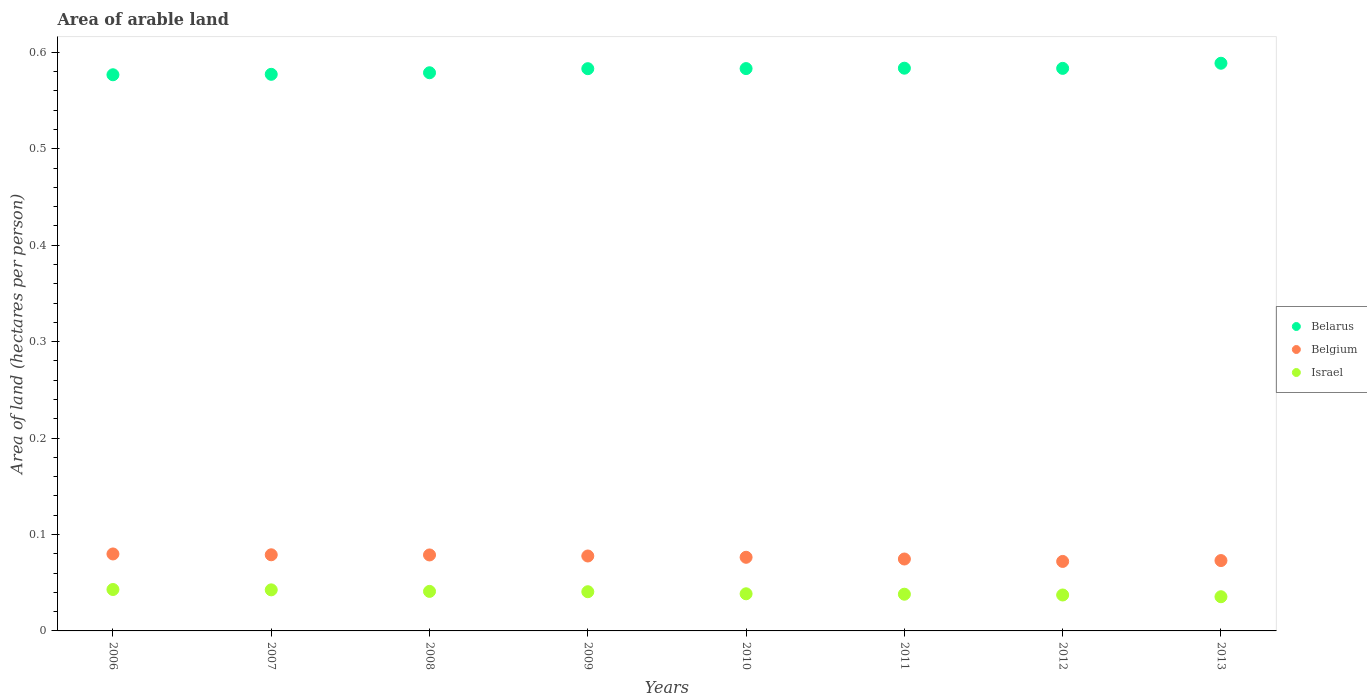How many different coloured dotlines are there?
Offer a terse response. 3. Is the number of dotlines equal to the number of legend labels?
Your answer should be very brief. Yes. What is the total arable land in Israel in 2007?
Offer a terse response. 0.04. Across all years, what is the maximum total arable land in Belarus?
Make the answer very short. 0.59. Across all years, what is the minimum total arable land in Belarus?
Keep it short and to the point. 0.58. In which year was the total arable land in Belgium maximum?
Ensure brevity in your answer.  2006. What is the total total arable land in Israel in the graph?
Provide a short and direct response. 0.32. What is the difference between the total arable land in Belgium in 2011 and that in 2013?
Give a very brief answer. 0. What is the difference between the total arable land in Belarus in 2006 and the total arable land in Belgium in 2010?
Provide a succinct answer. 0.5. What is the average total arable land in Belarus per year?
Your response must be concise. 0.58. In the year 2006, what is the difference between the total arable land in Belarus and total arable land in Belgium?
Provide a short and direct response. 0.5. In how many years, is the total arable land in Belarus greater than 0.54 hectares per person?
Keep it short and to the point. 8. What is the ratio of the total arable land in Israel in 2012 to that in 2013?
Your response must be concise. 1.05. Is the difference between the total arable land in Belarus in 2006 and 2011 greater than the difference between the total arable land in Belgium in 2006 and 2011?
Your answer should be compact. No. What is the difference between the highest and the second highest total arable land in Belgium?
Offer a very short reply. 0. What is the difference between the highest and the lowest total arable land in Belgium?
Keep it short and to the point. 0.01. Is the sum of the total arable land in Israel in 2008 and 2013 greater than the maximum total arable land in Belgium across all years?
Offer a terse response. No. Is the total arable land in Belarus strictly greater than the total arable land in Belgium over the years?
Give a very brief answer. Yes. How many dotlines are there?
Offer a very short reply. 3. How many years are there in the graph?
Your answer should be very brief. 8. What is the difference between two consecutive major ticks on the Y-axis?
Keep it short and to the point. 0.1. Are the values on the major ticks of Y-axis written in scientific E-notation?
Provide a short and direct response. No. Where does the legend appear in the graph?
Ensure brevity in your answer.  Center right. How are the legend labels stacked?
Offer a very short reply. Vertical. What is the title of the graph?
Provide a succinct answer. Area of arable land. What is the label or title of the X-axis?
Your response must be concise. Years. What is the label or title of the Y-axis?
Give a very brief answer. Area of land (hectares per person). What is the Area of land (hectares per person) in Belarus in 2006?
Provide a succinct answer. 0.58. What is the Area of land (hectares per person) in Belgium in 2006?
Your answer should be very brief. 0.08. What is the Area of land (hectares per person) in Israel in 2006?
Provide a succinct answer. 0.04. What is the Area of land (hectares per person) of Belarus in 2007?
Your response must be concise. 0.58. What is the Area of land (hectares per person) of Belgium in 2007?
Offer a terse response. 0.08. What is the Area of land (hectares per person) of Israel in 2007?
Ensure brevity in your answer.  0.04. What is the Area of land (hectares per person) of Belarus in 2008?
Provide a succinct answer. 0.58. What is the Area of land (hectares per person) of Belgium in 2008?
Make the answer very short. 0.08. What is the Area of land (hectares per person) of Israel in 2008?
Your answer should be very brief. 0.04. What is the Area of land (hectares per person) in Belarus in 2009?
Your answer should be compact. 0.58. What is the Area of land (hectares per person) of Belgium in 2009?
Offer a very short reply. 0.08. What is the Area of land (hectares per person) of Israel in 2009?
Keep it short and to the point. 0.04. What is the Area of land (hectares per person) of Belarus in 2010?
Offer a terse response. 0.58. What is the Area of land (hectares per person) of Belgium in 2010?
Offer a terse response. 0.08. What is the Area of land (hectares per person) in Israel in 2010?
Provide a short and direct response. 0.04. What is the Area of land (hectares per person) of Belarus in 2011?
Ensure brevity in your answer.  0.58. What is the Area of land (hectares per person) of Belgium in 2011?
Your answer should be compact. 0.07. What is the Area of land (hectares per person) in Israel in 2011?
Ensure brevity in your answer.  0.04. What is the Area of land (hectares per person) of Belarus in 2012?
Give a very brief answer. 0.58. What is the Area of land (hectares per person) of Belgium in 2012?
Your answer should be compact. 0.07. What is the Area of land (hectares per person) in Israel in 2012?
Keep it short and to the point. 0.04. What is the Area of land (hectares per person) of Belarus in 2013?
Offer a very short reply. 0.59. What is the Area of land (hectares per person) in Belgium in 2013?
Your answer should be very brief. 0.07. What is the Area of land (hectares per person) in Israel in 2013?
Provide a short and direct response. 0.04. Across all years, what is the maximum Area of land (hectares per person) of Belarus?
Keep it short and to the point. 0.59. Across all years, what is the maximum Area of land (hectares per person) in Belgium?
Offer a very short reply. 0.08. Across all years, what is the maximum Area of land (hectares per person) of Israel?
Keep it short and to the point. 0.04. Across all years, what is the minimum Area of land (hectares per person) in Belarus?
Offer a very short reply. 0.58. Across all years, what is the minimum Area of land (hectares per person) in Belgium?
Your answer should be compact. 0.07. Across all years, what is the minimum Area of land (hectares per person) of Israel?
Offer a terse response. 0.04. What is the total Area of land (hectares per person) in Belarus in the graph?
Keep it short and to the point. 4.66. What is the total Area of land (hectares per person) in Belgium in the graph?
Provide a succinct answer. 0.61. What is the total Area of land (hectares per person) of Israel in the graph?
Offer a terse response. 0.32. What is the difference between the Area of land (hectares per person) in Belarus in 2006 and that in 2007?
Provide a short and direct response. -0. What is the difference between the Area of land (hectares per person) in Belgium in 2006 and that in 2007?
Ensure brevity in your answer.  0. What is the difference between the Area of land (hectares per person) in Israel in 2006 and that in 2007?
Your response must be concise. 0. What is the difference between the Area of land (hectares per person) of Belarus in 2006 and that in 2008?
Offer a terse response. -0. What is the difference between the Area of land (hectares per person) in Israel in 2006 and that in 2008?
Give a very brief answer. 0. What is the difference between the Area of land (hectares per person) of Belarus in 2006 and that in 2009?
Ensure brevity in your answer.  -0.01. What is the difference between the Area of land (hectares per person) of Belgium in 2006 and that in 2009?
Offer a very short reply. 0. What is the difference between the Area of land (hectares per person) of Israel in 2006 and that in 2009?
Make the answer very short. 0. What is the difference between the Area of land (hectares per person) in Belarus in 2006 and that in 2010?
Your answer should be compact. -0.01. What is the difference between the Area of land (hectares per person) in Belgium in 2006 and that in 2010?
Keep it short and to the point. 0. What is the difference between the Area of land (hectares per person) in Israel in 2006 and that in 2010?
Offer a very short reply. 0. What is the difference between the Area of land (hectares per person) in Belarus in 2006 and that in 2011?
Ensure brevity in your answer.  -0.01. What is the difference between the Area of land (hectares per person) of Belgium in 2006 and that in 2011?
Give a very brief answer. 0.01. What is the difference between the Area of land (hectares per person) of Israel in 2006 and that in 2011?
Make the answer very short. 0. What is the difference between the Area of land (hectares per person) in Belarus in 2006 and that in 2012?
Make the answer very short. -0.01. What is the difference between the Area of land (hectares per person) of Belgium in 2006 and that in 2012?
Give a very brief answer. 0.01. What is the difference between the Area of land (hectares per person) of Israel in 2006 and that in 2012?
Your answer should be compact. 0.01. What is the difference between the Area of land (hectares per person) in Belarus in 2006 and that in 2013?
Provide a succinct answer. -0.01. What is the difference between the Area of land (hectares per person) in Belgium in 2006 and that in 2013?
Your answer should be compact. 0.01. What is the difference between the Area of land (hectares per person) in Israel in 2006 and that in 2013?
Your answer should be very brief. 0.01. What is the difference between the Area of land (hectares per person) in Belarus in 2007 and that in 2008?
Your answer should be compact. -0. What is the difference between the Area of land (hectares per person) of Belgium in 2007 and that in 2008?
Offer a very short reply. 0. What is the difference between the Area of land (hectares per person) in Israel in 2007 and that in 2008?
Ensure brevity in your answer.  0. What is the difference between the Area of land (hectares per person) in Belarus in 2007 and that in 2009?
Provide a succinct answer. -0.01. What is the difference between the Area of land (hectares per person) in Belgium in 2007 and that in 2009?
Your answer should be compact. 0. What is the difference between the Area of land (hectares per person) in Israel in 2007 and that in 2009?
Your answer should be very brief. 0. What is the difference between the Area of land (hectares per person) in Belarus in 2007 and that in 2010?
Ensure brevity in your answer.  -0.01. What is the difference between the Area of land (hectares per person) of Belgium in 2007 and that in 2010?
Provide a succinct answer. 0. What is the difference between the Area of land (hectares per person) in Israel in 2007 and that in 2010?
Ensure brevity in your answer.  0. What is the difference between the Area of land (hectares per person) of Belarus in 2007 and that in 2011?
Offer a very short reply. -0.01. What is the difference between the Area of land (hectares per person) of Belgium in 2007 and that in 2011?
Provide a succinct answer. 0. What is the difference between the Area of land (hectares per person) of Israel in 2007 and that in 2011?
Make the answer very short. 0. What is the difference between the Area of land (hectares per person) in Belarus in 2007 and that in 2012?
Give a very brief answer. -0.01. What is the difference between the Area of land (hectares per person) in Belgium in 2007 and that in 2012?
Your answer should be compact. 0.01. What is the difference between the Area of land (hectares per person) of Israel in 2007 and that in 2012?
Your response must be concise. 0.01. What is the difference between the Area of land (hectares per person) in Belarus in 2007 and that in 2013?
Make the answer very short. -0.01. What is the difference between the Area of land (hectares per person) of Belgium in 2007 and that in 2013?
Provide a short and direct response. 0.01. What is the difference between the Area of land (hectares per person) of Israel in 2007 and that in 2013?
Offer a terse response. 0.01. What is the difference between the Area of land (hectares per person) in Belarus in 2008 and that in 2009?
Give a very brief answer. -0. What is the difference between the Area of land (hectares per person) of Belgium in 2008 and that in 2009?
Keep it short and to the point. 0. What is the difference between the Area of land (hectares per person) in Israel in 2008 and that in 2009?
Keep it short and to the point. 0. What is the difference between the Area of land (hectares per person) in Belarus in 2008 and that in 2010?
Ensure brevity in your answer.  -0. What is the difference between the Area of land (hectares per person) of Belgium in 2008 and that in 2010?
Provide a short and direct response. 0. What is the difference between the Area of land (hectares per person) of Israel in 2008 and that in 2010?
Offer a very short reply. 0. What is the difference between the Area of land (hectares per person) of Belarus in 2008 and that in 2011?
Offer a very short reply. -0. What is the difference between the Area of land (hectares per person) in Belgium in 2008 and that in 2011?
Provide a succinct answer. 0. What is the difference between the Area of land (hectares per person) in Israel in 2008 and that in 2011?
Your answer should be compact. 0. What is the difference between the Area of land (hectares per person) of Belarus in 2008 and that in 2012?
Ensure brevity in your answer.  -0. What is the difference between the Area of land (hectares per person) of Belgium in 2008 and that in 2012?
Make the answer very short. 0.01. What is the difference between the Area of land (hectares per person) in Israel in 2008 and that in 2012?
Give a very brief answer. 0. What is the difference between the Area of land (hectares per person) of Belarus in 2008 and that in 2013?
Your answer should be very brief. -0.01. What is the difference between the Area of land (hectares per person) of Belgium in 2008 and that in 2013?
Keep it short and to the point. 0.01. What is the difference between the Area of land (hectares per person) in Israel in 2008 and that in 2013?
Your response must be concise. 0.01. What is the difference between the Area of land (hectares per person) in Belarus in 2009 and that in 2010?
Offer a terse response. -0. What is the difference between the Area of land (hectares per person) in Belgium in 2009 and that in 2010?
Ensure brevity in your answer.  0. What is the difference between the Area of land (hectares per person) of Israel in 2009 and that in 2010?
Offer a very short reply. 0. What is the difference between the Area of land (hectares per person) in Belarus in 2009 and that in 2011?
Your answer should be very brief. -0. What is the difference between the Area of land (hectares per person) of Belgium in 2009 and that in 2011?
Keep it short and to the point. 0. What is the difference between the Area of land (hectares per person) of Israel in 2009 and that in 2011?
Offer a very short reply. 0. What is the difference between the Area of land (hectares per person) in Belarus in 2009 and that in 2012?
Your answer should be compact. -0. What is the difference between the Area of land (hectares per person) in Belgium in 2009 and that in 2012?
Make the answer very short. 0.01. What is the difference between the Area of land (hectares per person) of Israel in 2009 and that in 2012?
Offer a very short reply. 0. What is the difference between the Area of land (hectares per person) in Belarus in 2009 and that in 2013?
Provide a succinct answer. -0.01. What is the difference between the Area of land (hectares per person) of Belgium in 2009 and that in 2013?
Provide a short and direct response. 0. What is the difference between the Area of land (hectares per person) of Israel in 2009 and that in 2013?
Provide a short and direct response. 0.01. What is the difference between the Area of land (hectares per person) in Belarus in 2010 and that in 2011?
Your response must be concise. -0. What is the difference between the Area of land (hectares per person) of Belgium in 2010 and that in 2011?
Provide a succinct answer. 0. What is the difference between the Area of land (hectares per person) of Belarus in 2010 and that in 2012?
Give a very brief answer. -0. What is the difference between the Area of land (hectares per person) of Belgium in 2010 and that in 2012?
Make the answer very short. 0. What is the difference between the Area of land (hectares per person) of Israel in 2010 and that in 2012?
Offer a very short reply. 0. What is the difference between the Area of land (hectares per person) in Belarus in 2010 and that in 2013?
Provide a short and direct response. -0.01. What is the difference between the Area of land (hectares per person) in Belgium in 2010 and that in 2013?
Provide a succinct answer. 0. What is the difference between the Area of land (hectares per person) of Israel in 2010 and that in 2013?
Make the answer very short. 0. What is the difference between the Area of land (hectares per person) of Belarus in 2011 and that in 2012?
Give a very brief answer. 0. What is the difference between the Area of land (hectares per person) in Belgium in 2011 and that in 2012?
Your answer should be compact. 0. What is the difference between the Area of land (hectares per person) of Israel in 2011 and that in 2012?
Keep it short and to the point. 0. What is the difference between the Area of land (hectares per person) of Belarus in 2011 and that in 2013?
Provide a succinct answer. -0.01. What is the difference between the Area of land (hectares per person) of Belgium in 2011 and that in 2013?
Your answer should be very brief. 0. What is the difference between the Area of land (hectares per person) in Israel in 2011 and that in 2013?
Offer a very short reply. 0. What is the difference between the Area of land (hectares per person) in Belarus in 2012 and that in 2013?
Your answer should be very brief. -0.01. What is the difference between the Area of land (hectares per person) in Belgium in 2012 and that in 2013?
Make the answer very short. -0. What is the difference between the Area of land (hectares per person) in Israel in 2012 and that in 2013?
Give a very brief answer. 0. What is the difference between the Area of land (hectares per person) of Belarus in 2006 and the Area of land (hectares per person) of Belgium in 2007?
Offer a very short reply. 0.5. What is the difference between the Area of land (hectares per person) in Belarus in 2006 and the Area of land (hectares per person) in Israel in 2007?
Your answer should be compact. 0.53. What is the difference between the Area of land (hectares per person) in Belgium in 2006 and the Area of land (hectares per person) in Israel in 2007?
Provide a succinct answer. 0.04. What is the difference between the Area of land (hectares per person) of Belarus in 2006 and the Area of land (hectares per person) of Belgium in 2008?
Ensure brevity in your answer.  0.5. What is the difference between the Area of land (hectares per person) in Belarus in 2006 and the Area of land (hectares per person) in Israel in 2008?
Offer a terse response. 0.54. What is the difference between the Area of land (hectares per person) of Belgium in 2006 and the Area of land (hectares per person) of Israel in 2008?
Your answer should be compact. 0.04. What is the difference between the Area of land (hectares per person) of Belarus in 2006 and the Area of land (hectares per person) of Belgium in 2009?
Offer a very short reply. 0.5. What is the difference between the Area of land (hectares per person) in Belarus in 2006 and the Area of land (hectares per person) in Israel in 2009?
Your answer should be compact. 0.54. What is the difference between the Area of land (hectares per person) of Belgium in 2006 and the Area of land (hectares per person) of Israel in 2009?
Your response must be concise. 0.04. What is the difference between the Area of land (hectares per person) in Belarus in 2006 and the Area of land (hectares per person) in Belgium in 2010?
Make the answer very short. 0.5. What is the difference between the Area of land (hectares per person) of Belarus in 2006 and the Area of land (hectares per person) of Israel in 2010?
Provide a short and direct response. 0.54. What is the difference between the Area of land (hectares per person) in Belgium in 2006 and the Area of land (hectares per person) in Israel in 2010?
Your response must be concise. 0.04. What is the difference between the Area of land (hectares per person) in Belarus in 2006 and the Area of land (hectares per person) in Belgium in 2011?
Provide a succinct answer. 0.5. What is the difference between the Area of land (hectares per person) in Belarus in 2006 and the Area of land (hectares per person) in Israel in 2011?
Offer a terse response. 0.54. What is the difference between the Area of land (hectares per person) in Belgium in 2006 and the Area of land (hectares per person) in Israel in 2011?
Make the answer very short. 0.04. What is the difference between the Area of land (hectares per person) in Belarus in 2006 and the Area of land (hectares per person) in Belgium in 2012?
Offer a terse response. 0.5. What is the difference between the Area of land (hectares per person) of Belarus in 2006 and the Area of land (hectares per person) of Israel in 2012?
Offer a terse response. 0.54. What is the difference between the Area of land (hectares per person) of Belgium in 2006 and the Area of land (hectares per person) of Israel in 2012?
Ensure brevity in your answer.  0.04. What is the difference between the Area of land (hectares per person) in Belarus in 2006 and the Area of land (hectares per person) in Belgium in 2013?
Give a very brief answer. 0.5. What is the difference between the Area of land (hectares per person) in Belarus in 2006 and the Area of land (hectares per person) in Israel in 2013?
Give a very brief answer. 0.54. What is the difference between the Area of land (hectares per person) in Belgium in 2006 and the Area of land (hectares per person) in Israel in 2013?
Provide a short and direct response. 0.04. What is the difference between the Area of land (hectares per person) of Belarus in 2007 and the Area of land (hectares per person) of Belgium in 2008?
Make the answer very short. 0.5. What is the difference between the Area of land (hectares per person) of Belarus in 2007 and the Area of land (hectares per person) of Israel in 2008?
Ensure brevity in your answer.  0.54. What is the difference between the Area of land (hectares per person) of Belgium in 2007 and the Area of land (hectares per person) of Israel in 2008?
Make the answer very short. 0.04. What is the difference between the Area of land (hectares per person) in Belarus in 2007 and the Area of land (hectares per person) in Belgium in 2009?
Offer a very short reply. 0.5. What is the difference between the Area of land (hectares per person) of Belarus in 2007 and the Area of land (hectares per person) of Israel in 2009?
Offer a terse response. 0.54. What is the difference between the Area of land (hectares per person) of Belgium in 2007 and the Area of land (hectares per person) of Israel in 2009?
Offer a very short reply. 0.04. What is the difference between the Area of land (hectares per person) of Belarus in 2007 and the Area of land (hectares per person) of Belgium in 2010?
Your answer should be compact. 0.5. What is the difference between the Area of land (hectares per person) in Belarus in 2007 and the Area of land (hectares per person) in Israel in 2010?
Offer a very short reply. 0.54. What is the difference between the Area of land (hectares per person) in Belgium in 2007 and the Area of land (hectares per person) in Israel in 2010?
Your answer should be compact. 0.04. What is the difference between the Area of land (hectares per person) of Belarus in 2007 and the Area of land (hectares per person) of Belgium in 2011?
Your response must be concise. 0.5. What is the difference between the Area of land (hectares per person) of Belarus in 2007 and the Area of land (hectares per person) of Israel in 2011?
Your answer should be compact. 0.54. What is the difference between the Area of land (hectares per person) in Belgium in 2007 and the Area of land (hectares per person) in Israel in 2011?
Your response must be concise. 0.04. What is the difference between the Area of land (hectares per person) in Belarus in 2007 and the Area of land (hectares per person) in Belgium in 2012?
Offer a terse response. 0.51. What is the difference between the Area of land (hectares per person) in Belarus in 2007 and the Area of land (hectares per person) in Israel in 2012?
Your response must be concise. 0.54. What is the difference between the Area of land (hectares per person) of Belgium in 2007 and the Area of land (hectares per person) of Israel in 2012?
Ensure brevity in your answer.  0.04. What is the difference between the Area of land (hectares per person) of Belarus in 2007 and the Area of land (hectares per person) of Belgium in 2013?
Your response must be concise. 0.5. What is the difference between the Area of land (hectares per person) of Belarus in 2007 and the Area of land (hectares per person) of Israel in 2013?
Provide a short and direct response. 0.54. What is the difference between the Area of land (hectares per person) of Belgium in 2007 and the Area of land (hectares per person) of Israel in 2013?
Your answer should be compact. 0.04. What is the difference between the Area of land (hectares per person) in Belarus in 2008 and the Area of land (hectares per person) in Belgium in 2009?
Give a very brief answer. 0.5. What is the difference between the Area of land (hectares per person) of Belarus in 2008 and the Area of land (hectares per person) of Israel in 2009?
Provide a short and direct response. 0.54. What is the difference between the Area of land (hectares per person) of Belgium in 2008 and the Area of land (hectares per person) of Israel in 2009?
Offer a very short reply. 0.04. What is the difference between the Area of land (hectares per person) of Belarus in 2008 and the Area of land (hectares per person) of Belgium in 2010?
Your response must be concise. 0.5. What is the difference between the Area of land (hectares per person) of Belarus in 2008 and the Area of land (hectares per person) of Israel in 2010?
Offer a terse response. 0.54. What is the difference between the Area of land (hectares per person) of Belgium in 2008 and the Area of land (hectares per person) of Israel in 2010?
Provide a short and direct response. 0.04. What is the difference between the Area of land (hectares per person) of Belarus in 2008 and the Area of land (hectares per person) of Belgium in 2011?
Your response must be concise. 0.5. What is the difference between the Area of land (hectares per person) in Belarus in 2008 and the Area of land (hectares per person) in Israel in 2011?
Offer a terse response. 0.54. What is the difference between the Area of land (hectares per person) in Belgium in 2008 and the Area of land (hectares per person) in Israel in 2011?
Ensure brevity in your answer.  0.04. What is the difference between the Area of land (hectares per person) in Belarus in 2008 and the Area of land (hectares per person) in Belgium in 2012?
Provide a succinct answer. 0.51. What is the difference between the Area of land (hectares per person) in Belarus in 2008 and the Area of land (hectares per person) in Israel in 2012?
Make the answer very short. 0.54. What is the difference between the Area of land (hectares per person) of Belgium in 2008 and the Area of land (hectares per person) of Israel in 2012?
Provide a short and direct response. 0.04. What is the difference between the Area of land (hectares per person) in Belarus in 2008 and the Area of land (hectares per person) in Belgium in 2013?
Make the answer very short. 0.51. What is the difference between the Area of land (hectares per person) of Belarus in 2008 and the Area of land (hectares per person) of Israel in 2013?
Give a very brief answer. 0.54. What is the difference between the Area of land (hectares per person) in Belgium in 2008 and the Area of land (hectares per person) in Israel in 2013?
Give a very brief answer. 0.04. What is the difference between the Area of land (hectares per person) of Belarus in 2009 and the Area of land (hectares per person) of Belgium in 2010?
Your answer should be very brief. 0.51. What is the difference between the Area of land (hectares per person) of Belarus in 2009 and the Area of land (hectares per person) of Israel in 2010?
Offer a terse response. 0.54. What is the difference between the Area of land (hectares per person) of Belgium in 2009 and the Area of land (hectares per person) of Israel in 2010?
Ensure brevity in your answer.  0.04. What is the difference between the Area of land (hectares per person) of Belarus in 2009 and the Area of land (hectares per person) of Belgium in 2011?
Ensure brevity in your answer.  0.51. What is the difference between the Area of land (hectares per person) in Belarus in 2009 and the Area of land (hectares per person) in Israel in 2011?
Offer a terse response. 0.55. What is the difference between the Area of land (hectares per person) of Belgium in 2009 and the Area of land (hectares per person) of Israel in 2011?
Your answer should be compact. 0.04. What is the difference between the Area of land (hectares per person) in Belarus in 2009 and the Area of land (hectares per person) in Belgium in 2012?
Offer a very short reply. 0.51. What is the difference between the Area of land (hectares per person) of Belarus in 2009 and the Area of land (hectares per person) of Israel in 2012?
Provide a succinct answer. 0.55. What is the difference between the Area of land (hectares per person) of Belgium in 2009 and the Area of land (hectares per person) of Israel in 2012?
Ensure brevity in your answer.  0.04. What is the difference between the Area of land (hectares per person) in Belarus in 2009 and the Area of land (hectares per person) in Belgium in 2013?
Your response must be concise. 0.51. What is the difference between the Area of land (hectares per person) in Belarus in 2009 and the Area of land (hectares per person) in Israel in 2013?
Provide a succinct answer. 0.55. What is the difference between the Area of land (hectares per person) in Belgium in 2009 and the Area of land (hectares per person) in Israel in 2013?
Your response must be concise. 0.04. What is the difference between the Area of land (hectares per person) in Belarus in 2010 and the Area of land (hectares per person) in Belgium in 2011?
Make the answer very short. 0.51. What is the difference between the Area of land (hectares per person) in Belarus in 2010 and the Area of land (hectares per person) in Israel in 2011?
Ensure brevity in your answer.  0.55. What is the difference between the Area of land (hectares per person) in Belgium in 2010 and the Area of land (hectares per person) in Israel in 2011?
Offer a very short reply. 0.04. What is the difference between the Area of land (hectares per person) in Belarus in 2010 and the Area of land (hectares per person) in Belgium in 2012?
Your answer should be compact. 0.51. What is the difference between the Area of land (hectares per person) in Belarus in 2010 and the Area of land (hectares per person) in Israel in 2012?
Your answer should be very brief. 0.55. What is the difference between the Area of land (hectares per person) in Belgium in 2010 and the Area of land (hectares per person) in Israel in 2012?
Offer a very short reply. 0.04. What is the difference between the Area of land (hectares per person) of Belarus in 2010 and the Area of land (hectares per person) of Belgium in 2013?
Keep it short and to the point. 0.51. What is the difference between the Area of land (hectares per person) of Belarus in 2010 and the Area of land (hectares per person) of Israel in 2013?
Make the answer very short. 0.55. What is the difference between the Area of land (hectares per person) in Belgium in 2010 and the Area of land (hectares per person) in Israel in 2013?
Ensure brevity in your answer.  0.04. What is the difference between the Area of land (hectares per person) in Belarus in 2011 and the Area of land (hectares per person) in Belgium in 2012?
Provide a short and direct response. 0.51. What is the difference between the Area of land (hectares per person) in Belarus in 2011 and the Area of land (hectares per person) in Israel in 2012?
Make the answer very short. 0.55. What is the difference between the Area of land (hectares per person) of Belgium in 2011 and the Area of land (hectares per person) of Israel in 2012?
Your response must be concise. 0.04. What is the difference between the Area of land (hectares per person) in Belarus in 2011 and the Area of land (hectares per person) in Belgium in 2013?
Make the answer very short. 0.51. What is the difference between the Area of land (hectares per person) in Belarus in 2011 and the Area of land (hectares per person) in Israel in 2013?
Ensure brevity in your answer.  0.55. What is the difference between the Area of land (hectares per person) in Belgium in 2011 and the Area of land (hectares per person) in Israel in 2013?
Provide a short and direct response. 0.04. What is the difference between the Area of land (hectares per person) of Belarus in 2012 and the Area of land (hectares per person) of Belgium in 2013?
Give a very brief answer. 0.51. What is the difference between the Area of land (hectares per person) of Belarus in 2012 and the Area of land (hectares per person) of Israel in 2013?
Ensure brevity in your answer.  0.55. What is the difference between the Area of land (hectares per person) in Belgium in 2012 and the Area of land (hectares per person) in Israel in 2013?
Provide a succinct answer. 0.04. What is the average Area of land (hectares per person) in Belarus per year?
Provide a succinct answer. 0.58. What is the average Area of land (hectares per person) in Belgium per year?
Offer a very short reply. 0.08. What is the average Area of land (hectares per person) of Israel per year?
Offer a terse response. 0.04. In the year 2006, what is the difference between the Area of land (hectares per person) of Belarus and Area of land (hectares per person) of Belgium?
Provide a succinct answer. 0.5. In the year 2006, what is the difference between the Area of land (hectares per person) of Belarus and Area of land (hectares per person) of Israel?
Ensure brevity in your answer.  0.53. In the year 2006, what is the difference between the Area of land (hectares per person) in Belgium and Area of land (hectares per person) in Israel?
Provide a short and direct response. 0.04. In the year 2007, what is the difference between the Area of land (hectares per person) in Belarus and Area of land (hectares per person) in Belgium?
Ensure brevity in your answer.  0.5. In the year 2007, what is the difference between the Area of land (hectares per person) of Belarus and Area of land (hectares per person) of Israel?
Make the answer very short. 0.53. In the year 2007, what is the difference between the Area of land (hectares per person) in Belgium and Area of land (hectares per person) in Israel?
Your response must be concise. 0.04. In the year 2008, what is the difference between the Area of land (hectares per person) of Belarus and Area of land (hectares per person) of Belgium?
Your response must be concise. 0.5. In the year 2008, what is the difference between the Area of land (hectares per person) of Belarus and Area of land (hectares per person) of Israel?
Provide a short and direct response. 0.54. In the year 2008, what is the difference between the Area of land (hectares per person) of Belgium and Area of land (hectares per person) of Israel?
Your answer should be compact. 0.04. In the year 2009, what is the difference between the Area of land (hectares per person) of Belarus and Area of land (hectares per person) of Belgium?
Provide a short and direct response. 0.51. In the year 2009, what is the difference between the Area of land (hectares per person) in Belarus and Area of land (hectares per person) in Israel?
Ensure brevity in your answer.  0.54. In the year 2009, what is the difference between the Area of land (hectares per person) in Belgium and Area of land (hectares per person) in Israel?
Offer a very short reply. 0.04. In the year 2010, what is the difference between the Area of land (hectares per person) of Belarus and Area of land (hectares per person) of Belgium?
Your response must be concise. 0.51. In the year 2010, what is the difference between the Area of land (hectares per person) in Belarus and Area of land (hectares per person) in Israel?
Your response must be concise. 0.54. In the year 2010, what is the difference between the Area of land (hectares per person) in Belgium and Area of land (hectares per person) in Israel?
Provide a short and direct response. 0.04. In the year 2011, what is the difference between the Area of land (hectares per person) of Belarus and Area of land (hectares per person) of Belgium?
Provide a succinct answer. 0.51. In the year 2011, what is the difference between the Area of land (hectares per person) in Belarus and Area of land (hectares per person) in Israel?
Offer a terse response. 0.55. In the year 2011, what is the difference between the Area of land (hectares per person) in Belgium and Area of land (hectares per person) in Israel?
Your response must be concise. 0.04. In the year 2012, what is the difference between the Area of land (hectares per person) of Belarus and Area of land (hectares per person) of Belgium?
Make the answer very short. 0.51. In the year 2012, what is the difference between the Area of land (hectares per person) in Belarus and Area of land (hectares per person) in Israel?
Give a very brief answer. 0.55. In the year 2012, what is the difference between the Area of land (hectares per person) in Belgium and Area of land (hectares per person) in Israel?
Offer a terse response. 0.03. In the year 2013, what is the difference between the Area of land (hectares per person) of Belarus and Area of land (hectares per person) of Belgium?
Keep it short and to the point. 0.52. In the year 2013, what is the difference between the Area of land (hectares per person) of Belarus and Area of land (hectares per person) of Israel?
Offer a terse response. 0.55. In the year 2013, what is the difference between the Area of land (hectares per person) of Belgium and Area of land (hectares per person) of Israel?
Offer a very short reply. 0.04. What is the ratio of the Area of land (hectares per person) in Belarus in 2006 to that in 2007?
Offer a terse response. 1. What is the ratio of the Area of land (hectares per person) of Israel in 2006 to that in 2007?
Provide a short and direct response. 1.01. What is the ratio of the Area of land (hectares per person) in Israel in 2006 to that in 2008?
Offer a terse response. 1.05. What is the ratio of the Area of land (hectares per person) of Belgium in 2006 to that in 2009?
Provide a succinct answer. 1.03. What is the ratio of the Area of land (hectares per person) in Israel in 2006 to that in 2009?
Keep it short and to the point. 1.06. What is the ratio of the Area of land (hectares per person) in Belgium in 2006 to that in 2010?
Offer a terse response. 1.05. What is the ratio of the Area of land (hectares per person) in Israel in 2006 to that in 2010?
Make the answer very short. 1.12. What is the ratio of the Area of land (hectares per person) in Belarus in 2006 to that in 2011?
Make the answer very short. 0.99. What is the ratio of the Area of land (hectares per person) of Belgium in 2006 to that in 2011?
Provide a short and direct response. 1.07. What is the ratio of the Area of land (hectares per person) of Israel in 2006 to that in 2011?
Keep it short and to the point. 1.13. What is the ratio of the Area of land (hectares per person) of Belarus in 2006 to that in 2012?
Your response must be concise. 0.99. What is the ratio of the Area of land (hectares per person) of Belgium in 2006 to that in 2012?
Your answer should be compact. 1.11. What is the ratio of the Area of land (hectares per person) in Israel in 2006 to that in 2012?
Make the answer very short. 1.15. What is the ratio of the Area of land (hectares per person) of Belarus in 2006 to that in 2013?
Make the answer very short. 0.98. What is the ratio of the Area of land (hectares per person) in Belgium in 2006 to that in 2013?
Offer a very short reply. 1.09. What is the ratio of the Area of land (hectares per person) in Israel in 2006 to that in 2013?
Provide a succinct answer. 1.21. What is the ratio of the Area of land (hectares per person) of Belarus in 2007 to that in 2008?
Your answer should be very brief. 1. What is the ratio of the Area of land (hectares per person) of Israel in 2007 to that in 2008?
Ensure brevity in your answer.  1.04. What is the ratio of the Area of land (hectares per person) of Belgium in 2007 to that in 2009?
Ensure brevity in your answer.  1.02. What is the ratio of the Area of land (hectares per person) of Israel in 2007 to that in 2009?
Give a very brief answer. 1.05. What is the ratio of the Area of land (hectares per person) of Belarus in 2007 to that in 2010?
Ensure brevity in your answer.  0.99. What is the ratio of the Area of land (hectares per person) of Belgium in 2007 to that in 2010?
Give a very brief answer. 1.03. What is the ratio of the Area of land (hectares per person) of Israel in 2007 to that in 2010?
Your response must be concise. 1.11. What is the ratio of the Area of land (hectares per person) of Belgium in 2007 to that in 2011?
Give a very brief answer. 1.06. What is the ratio of the Area of land (hectares per person) of Israel in 2007 to that in 2011?
Offer a very short reply. 1.12. What is the ratio of the Area of land (hectares per person) in Belgium in 2007 to that in 2012?
Provide a succinct answer. 1.1. What is the ratio of the Area of land (hectares per person) in Israel in 2007 to that in 2012?
Ensure brevity in your answer.  1.14. What is the ratio of the Area of land (hectares per person) of Belarus in 2007 to that in 2013?
Offer a terse response. 0.98. What is the ratio of the Area of land (hectares per person) in Belgium in 2007 to that in 2013?
Ensure brevity in your answer.  1.08. What is the ratio of the Area of land (hectares per person) of Israel in 2007 to that in 2013?
Provide a succinct answer. 1.2. What is the ratio of the Area of land (hectares per person) of Belgium in 2008 to that in 2009?
Provide a succinct answer. 1.01. What is the ratio of the Area of land (hectares per person) of Israel in 2008 to that in 2009?
Offer a very short reply. 1.01. What is the ratio of the Area of land (hectares per person) in Belgium in 2008 to that in 2010?
Your answer should be very brief. 1.03. What is the ratio of the Area of land (hectares per person) of Israel in 2008 to that in 2010?
Offer a terse response. 1.06. What is the ratio of the Area of land (hectares per person) of Belgium in 2008 to that in 2011?
Keep it short and to the point. 1.06. What is the ratio of the Area of land (hectares per person) of Belarus in 2008 to that in 2012?
Provide a short and direct response. 0.99. What is the ratio of the Area of land (hectares per person) in Belgium in 2008 to that in 2012?
Your answer should be compact. 1.09. What is the ratio of the Area of land (hectares per person) in Israel in 2008 to that in 2012?
Ensure brevity in your answer.  1.1. What is the ratio of the Area of land (hectares per person) in Belarus in 2008 to that in 2013?
Give a very brief answer. 0.98. What is the ratio of the Area of land (hectares per person) in Belgium in 2008 to that in 2013?
Offer a very short reply. 1.08. What is the ratio of the Area of land (hectares per person) of Israel in 2008 to that in 2013?
Provide a short and direct response. 1.16. What is the ratio of the Area of land (hectares per person) in Belarus in 2009 to that in 2010?
Keep it short and to the point. 1. What is the ratio of the Area of land (hectares per person) in Belgium in 2009 to that in 2010?
Ensure brevity in your answer.  1.02. What is the ratio of the Area of land (hectares per person) of Israel in 2009 to that in 2010?
Your response must be concise. 1.06. What is the ratio of the Area of land (hectares per person) in Belarus in 2009 to that in 2011?
Your answer should be very brief. 1. What is the ratio of the Area of land (hectares per person) in Belgium in 2009 to that in 2011?
Ensure brevity in your answer.  1.04. What is the ratio of the Area of land (hectares per person) in Israel in 2009 to that in 2011?
Provide a succinct answer. 1.07. What is the ratio of the Area of land (hectares per person) of Belgium in 2009 to that in 2012?
Make the answer very short. 1.08. What is the ratio of the Area of land (hectares per person) in Israel in 2009 to that in 2012?
Your answer should be very brief. 1.09. What is the ratio of the Area of land (hectares per person) of Belgium in 2009 to that in 2013?
Your answer should be compact. 1.06. What is the ratio of the Area of land (hectares per person) in Israel in 2009 to that in 2013?
Make the answer very short. 1.15. What is the ratio of the Area of land (hectares per person) in Belarus in 2010 to that in 2011?
Keep it short and to the point. 1. What is the ratio of the Area of land (hectares per person) of Israel in 2010 to that in 2011?
Your answer should be very brief. 1.01. What is the ratio of the Area of land (hectares per person) of Belarus in 2010 to that in 2012?
Provide a short and direct response. 1. What is the ratio of the Area of land (hectares per person) of Belgium in 2010 to that in 2012?
Offer a very short reply. 1.06. What is the ratio of the Area of land (hectares per person) in Israel in 2010 to that in 2012?
Ensure brevity in your answer.  1.03. What is the ratio of the Area of land (hectares per person) of Belarus in 2010 to that in 2013?
Offer a terse response. 0.99. What is the ratio of the Area of land (hectares per person) in Belgium in 2010 to that in 2013?
Provide a succinct answer. 1.05. What is the ratio of the Area of land (hectares per person) of Israel in 2010 to that in 2013?
Your response must be concise. 1.09. What is the ratio of the Area of land (hectares per person) of Belarus in 2011 to that in 2012?
Offer a terse response. 1. What is the ratio of the Area of land (hectares per person) in Belgium in 2011 to that in 2012?
Offer a terse response. 1.03. What is the ratio of the Area of land (hectares per person) in Israel in 2011 to that in 2012?
Your answer should be very brief. 1.02. What is the ratio of the Area of land (hectares per person) in Belgium in 2011 to that in 2013?
Provide a succinct answer. 1.02. What is the ratio of the Area of land (hectares per person) in Israel in 2011 to that in 2013?
Keep it short and to the point. 1.07. What is the ratio of the Area of land (hectares per person) of Israel in 2012 to that in 2013?
Your response must be concise. 1.05. What is the difference between the highest and the second highest Area of land (hectares per person) in Belarus?
Provide a short and direct response. 0.01. What is the difference between the highest and the second highest Area of land (hectares per person) in Belgium?
Keep it short and to the point. 0. What is the difference between the highest and the second highest Area of land (hectares per person) of Israel?
Offer a terse response. 0. What is the difference between the highest and the lowest Area of land (hectares per person) of Belarus?
Provide a short and direct response. 0.01. What is the difference between the highest and the lowest Area of land (hectares per person) in Belgium?
Your response must be concise. 0.01. What is the difference between the highest and the lowest Area of land (hectares per person) of Israel?
Provide a short and direct response. 0.01. 